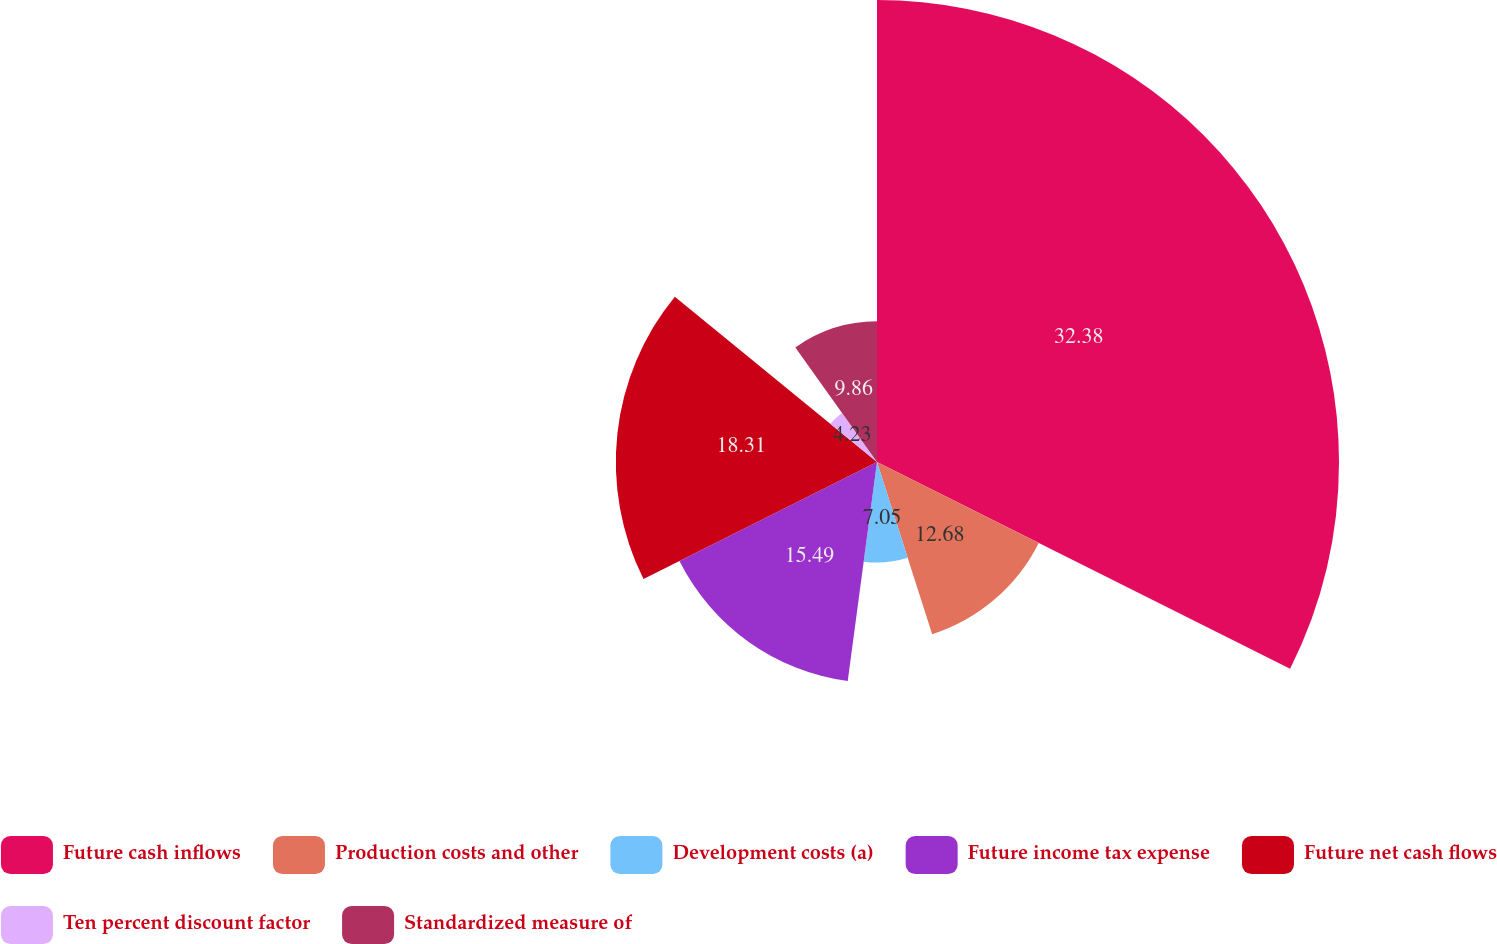<chart> <loc_0><loc_0><loc_500><loc_500><pie_chart><fcel>Future cash inflows<fcel>Production costs and other<fcel>Development costs (a)<fcel>Future income tax expense<fcel>Future net cash flows<fcel>Ten percent discount factor<fcel>Standardized measure of<nl><fcel>32.39%<fcel>12.68%<fcel>7.05%<fcel>15.49%<fcel>18.31%<fcel>4.23%<fcel>9.86%<nl></chart> 